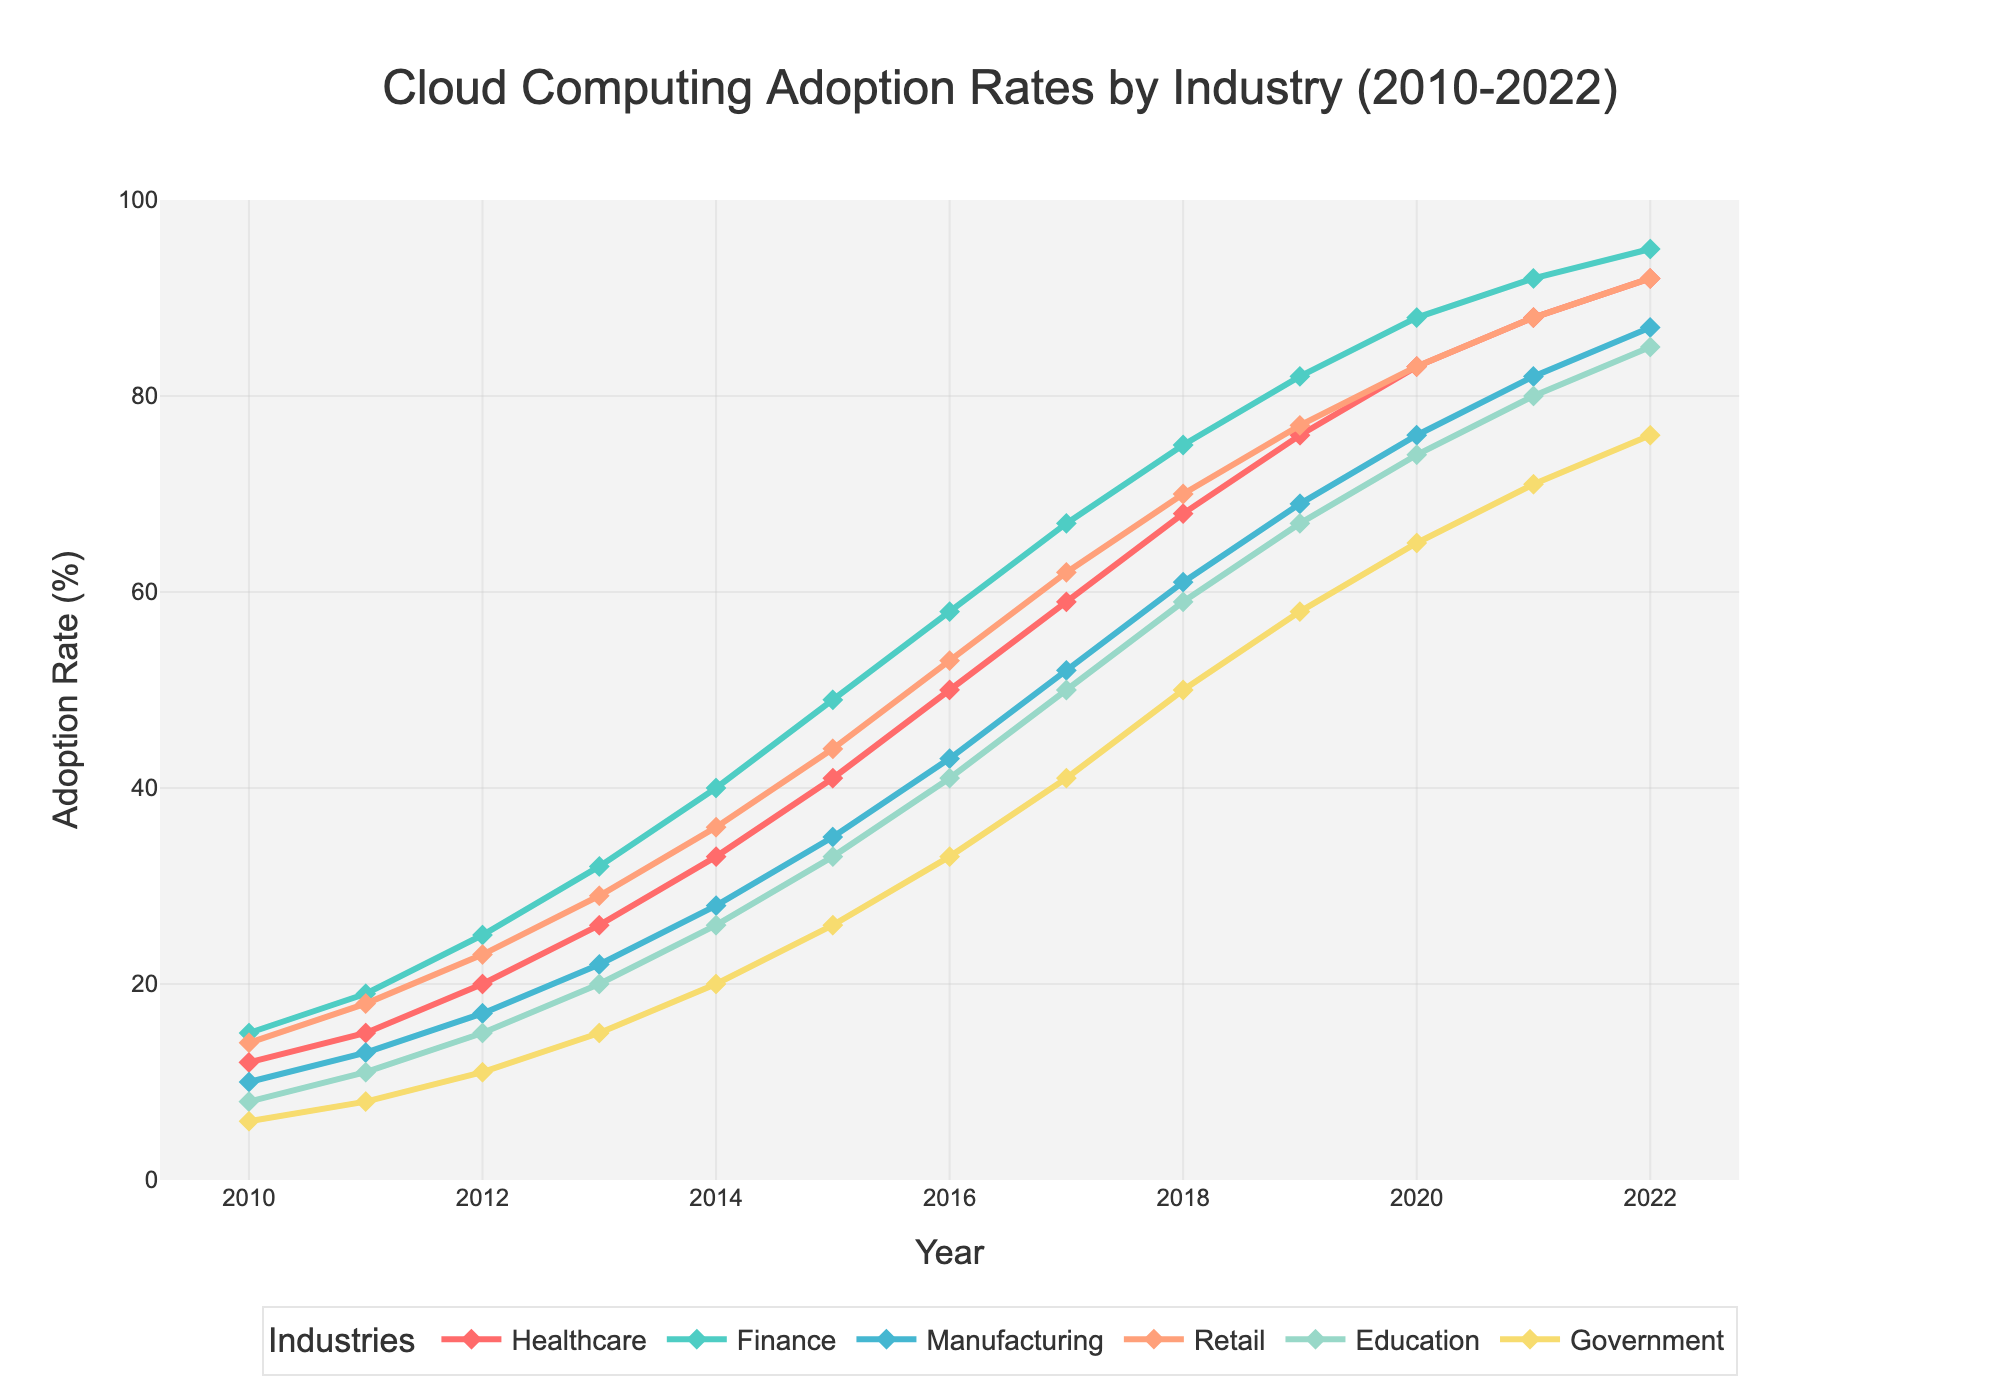what is the adoption rate for the healthcare industry in 2015? Locate 2015 on the x-axis and find the corresponding value on the curve for the Healthcare industry, which is marked in red. The value is 41%
Answer: 41% Which industry had the highest adoption rate in 2022? Look for the highest point on the y-axis in 2022 and note the industry color/label. Finance had the highest adoption rate with 95%.
Answer: Finance What industry showed the most significant growth from 2010 to 2022? Calculate the difference in adoption rates between 2010 and 2022 for each industry and compare the differences. Finance grew from 15% to 95%, a total of 80 percentage points, which is the highest growth.
Answer: Finance Between Retail and Education, which had a higher adoption rate in 2018? Locate 2018 on the x-axis and compare the values of Retail and Education, which are marked in salmon and teal, respectively. Retail shows 70%, whereas Education shows 59%. Therefore, Retail had a higher adoption rate.
Answer: Retail How many percentage points did Government adoption increase between 2012 and 2016? Find the values for Government in 2012 (11%) and 2016 (33%), then calculate the difference: 33% - 11% = 22%.
Answer: 22% Which industry had the least change in adoption rate between 2020 and 2022? Find the adoption rates for all industries in 2020 and 2022, calculate the difference for each, and the smallest difference is the least change. Government had the least change (from 65% to 76%, a 11 percentage points increase).
Answer: Government Is the adoption rate for the Healthcare industry in 2014 lower than that for Manufacturing in 2016? Compare the adoption rate for Healthcare in 2014 (33%) and Manufacturing in 2016 (43%). Yes, 33% is lower than 43%.
Answer: Yes What is the average adoption rate of the Finance industry over the entire period? Sum the adoption rates for Finance for every year and divide by the number of years. (15+19+25+32+40+49+58+67+75+82+88+92+95)/13 = 54.077 approximately 54.1%
Answer: 54.1% Which industry first reached an adoption rate of 50%? Identify the earliest year in which any industry's adoption rate first exceeded 50%. Healthcare reached 50% in 2016.
Answer: Healthcare 